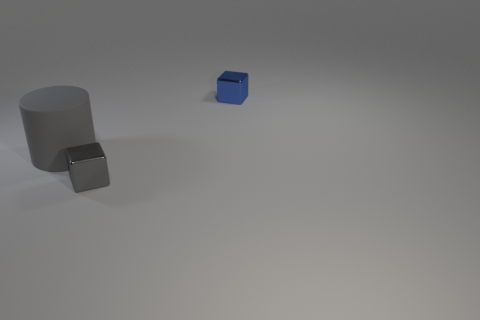The thing that is both to the left of the small blue metallic object and behind the gray metallic object has what shape?
Keep it short and to the point. Cylinder. There is another object that is the same shape as the small gray object; what color is it?
Your response must be concise. Blue. Is there anything else that is the same color as the big cylinder?
Your response must be concise. Yes. There is a thing right of the small thing on the left side of the tiny thing behind the big gray matte cylinder; what shape is it?
Give a very brief answer. Cube. Is the size of the shiny object that is in front of the blue block the same as the shiny object behind the gray matte cylinder?
Provide a succinct answer. Yes. What number of cubes are made of the same material as the gray cylinder?
Your response must be concise. 0. How many matte objects are in front of the cube on the right side of the small object left of the tiny blue thing?
Your answer should be very brief. 1. Is the shape of the blue object the same as the big object?
Offer a terse response. No. Is there another big gray thing that has the same shape as the big gray matte object?
Your answer should be very brief. No. There is a gray metallic object that is the same size as the blue metal block; what shape is it?
Provide a short and direct response. Cube. 